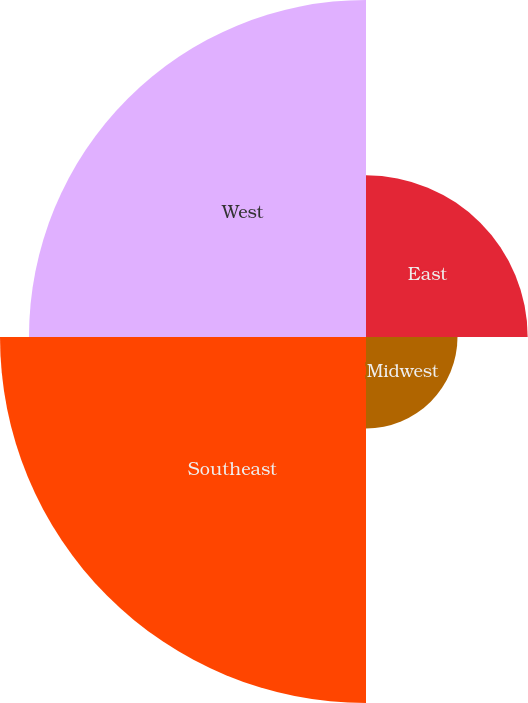Convert chart. <chart><loc_0><loc_0><loc_500><loc_500><pie_chart><fcel>East<fcel>Midwest<fcel>Southeast<fcel>West<nl><fcel>16.91%<fcel>9.57%<fcel>38.28%<fcel>35.25%<nl></chart> 